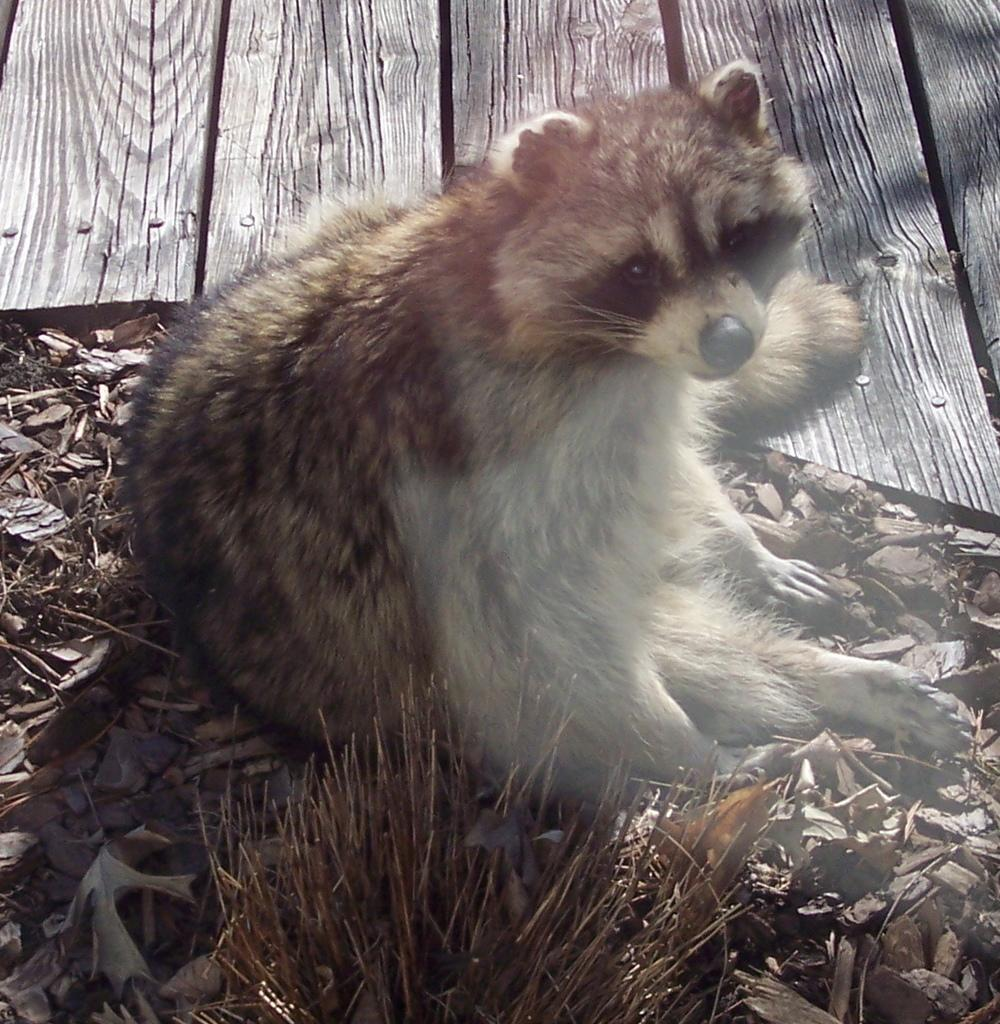What is the main subject of the image? There is a Punxsutawney Phil in the image. What is the Punxsutawney Phil sitting on? The Punxsutawney Phil is sitting on dried leaves. What can be seen beside the Punxsutawney Phil? There is a wooden object beside the Punxsutawney Phil. What type of dress is the Punxsutawney Phil wearing in the image? Punxsutawney Phil is a groundhog and does not wear clothing, so there is no dress present in the image. 